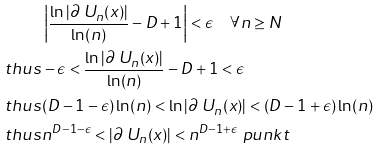Convert formula to latex. <formula><loc_0><loc_0><loc_500><loc_500>& \left | \frac { \ln | \partial \ U _ { n } ( x ) | } { \ln ( n ) } - D + 1 \right | < \epsilon \quad \forall n \geq N \\ \ t h u s & - \epsilon < \frac { \ln | \partial \ U _ { n } ( x ) | } { \ln ( n ) } - D + 1 < \epsilon \\ \ t h u s & ( D - 1 - \epsilon ) \ln ( n ) < \ln | \partial \ U _ { n } ( x ) | < ( D - 1 + \epsilon ) \ln ( n ) \\ \ t h u s & n ^ { D - 1 - \epsilon } < | \partial \ U _ { n } ( x ) | < n ^ { D - 1 + \epsilon } \ p u n k t</formula> 